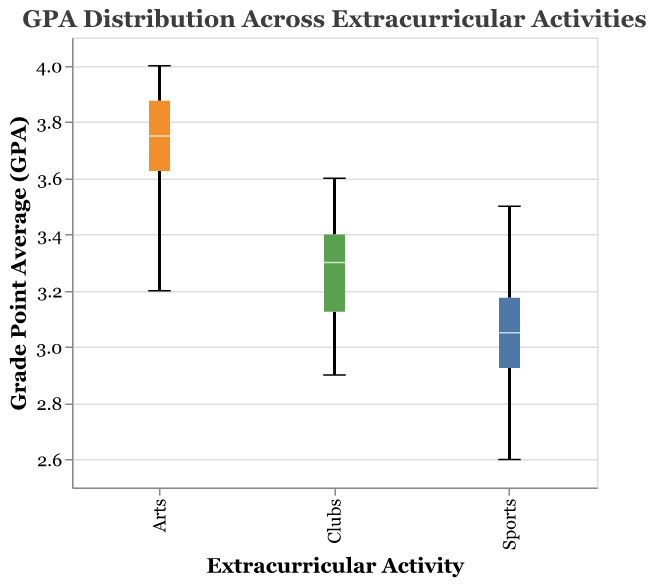What is the title of the box plot? The title is usually found at the top of the plot. In this case, it is "GPA Distribution Across Extracurricular Activities".
Answer: GPA Distribution Across Extracurricular Activities Which group has the highest median GPA? The median GPA is the middle line within the box of the box plot. By comparing the median lines, the group 'Arts' has the highest median GPA.
Answer: Arts What is the range of GPAs for students participating in Sports? The range is the difference between the maximum and minimum values. The Sports group has a minimum GPA of 2.6 and a maximum GPA of 3.5. The range is 3.5 - 2.6.
Answer: 0.9 How does the interquartile range (IQR) of the Clubs group compare to that of the Arts group? The IQR is the distance between the first quartile (bottom of the box) and the third quartile (top of the box). Visually inspecting the box plots, the IQR of Arts appears larger than that of Clubs.
Answer: Arts > Clubs Which group has the highest maximum GPA value? The maximum GPA is the highest value shown by the whiskers of the box plots. For the groups shown, 'Arts' has the highest maximum GPA of 4.0.
Answer: Arts What is the median GPA for students in the Clubs group? The median is indicated by the horizontal line within the box of the box plot. For the Clubs group, the median GPA is around 3.3.
Answer: 3.3 Compare the spread of GPA values for students in Sports and Clubs. Which group has a wider spread? The spread of GPA values can be observed by looking at the length of the whiskers from the minimum to maximum values. The Sports group has a range from 2.6 to 3.5 (0.9), while the Clubs group ranges from 2.9 to 3.6 (0.7). Thus, 'Sports' has a wider spread.
Answer: Sports What is the lowest GPA recorded in the Arts group? The lowest value in the figure can be seen at the bottom whisker of the box plot for the Arts group. It is 3.2.
Answer: 3.2 Which extracurricular activity has the largest variability in GPA scores? Variability in GPA scores can be observed by the length of the boxes and whiskers. 'Sports' shows the largest variability since its range and spread are the widest.
Answer: Sports 